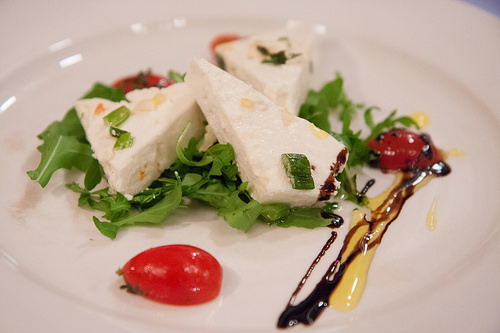<image>
Is the lettuce on the plate? Yes. Looking at the image, I can see the lettuce is positioned on top of the plate, with the plate providing support. 